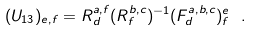Convert formula to latex. <formula><loc_0><loc_0><loc_500><loc_500>( U _ { 1 3 } ) _ { e , f } = R ^ { a , f } _ { d } ( R ^ { b , c } _ { f } ) ^ { - 1 } ( F ^ { a , b , c } _ { d } ) ^ { e } _ { f } \ .</formula> 